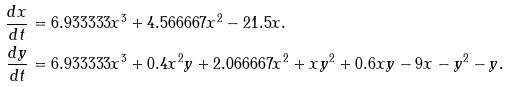<formula> <loc_0><loc_0><loc_500><loc_500>\frac { d x } { d t } & = 6 . 9 3 3 3 3 3 x ^ { 3 } + 4 . 5 6 6 6 6 7 x ^ { 2 } - 2 1 . 5 x . \\ \frac { d y } { d t } & = 6 . 9 3 3 3 3 3 x ^ { 3 } + 0 . 4 x ^ { 2 } y + 2 . 0 6 6 6 6 7 x ^ { 2 } + x y ^ { 2 } + 0 . 6 x y - 9 x - y ^ { 2 } - y . \\</formula> 